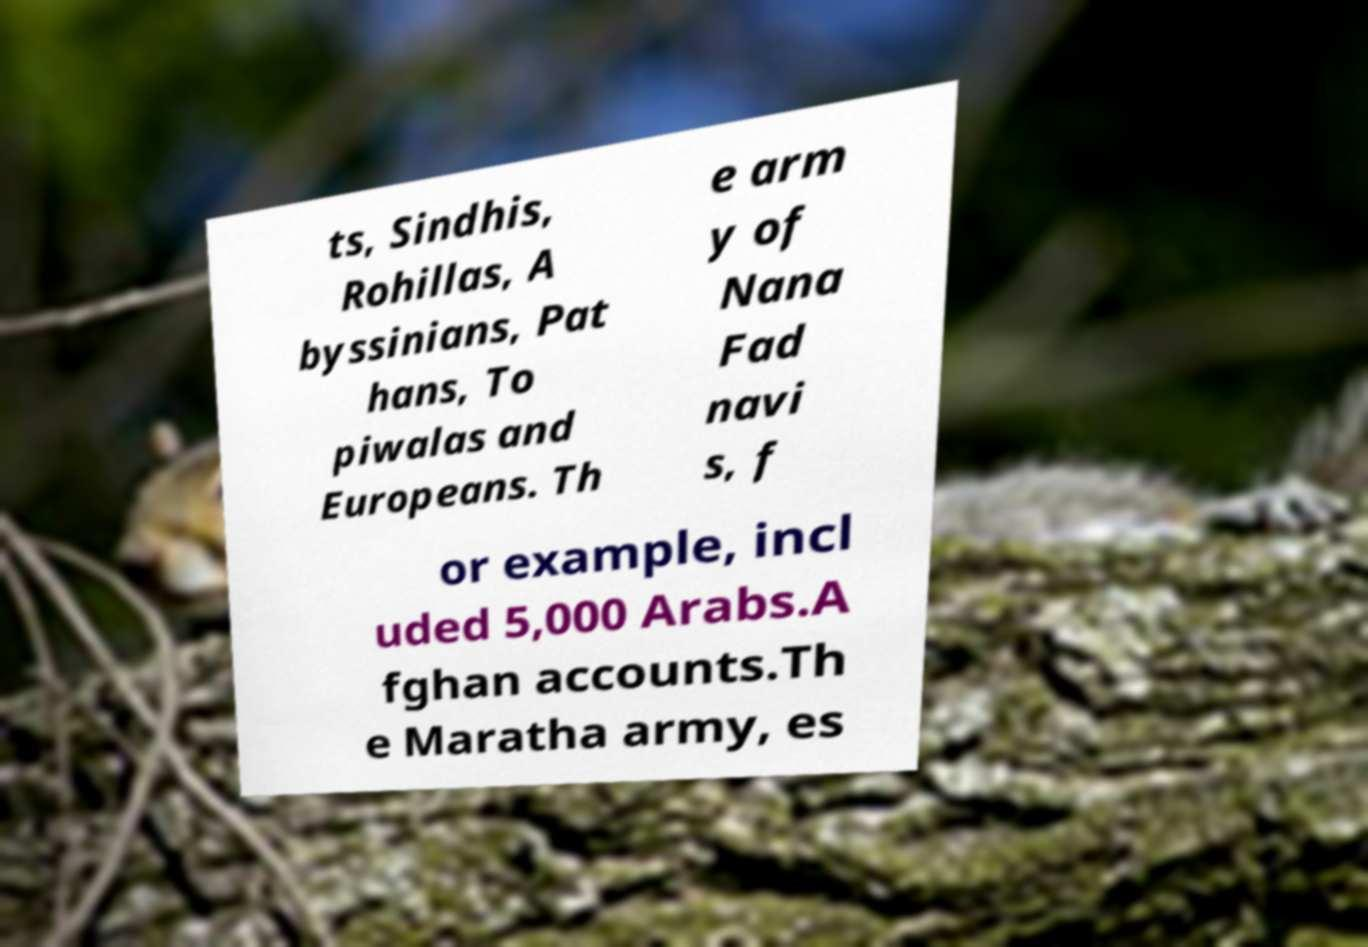I need the written content from this picture converted into text. Can you do that? ts, Sindhis, Rohillas, A byssinians, Pat hans, To piwalas and Europeans. Th e arm y of Nana Fad navi s, f or example, incl uded 5,000 Arabs.A fghan accounts.Th e Maratha army, es 